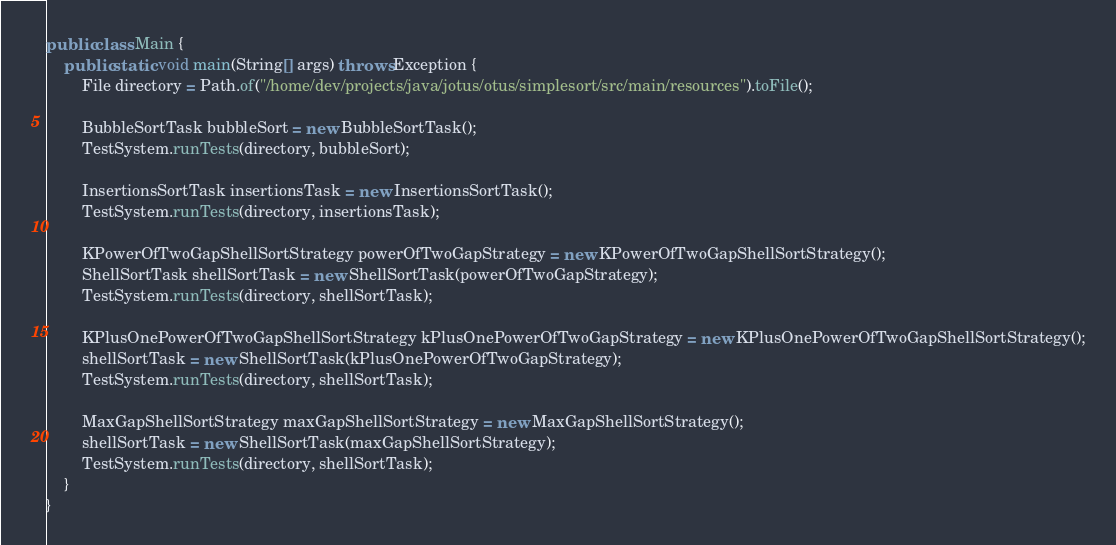<code> <loc_0><loc_0><loc_500><loc_500><_Java_>
public class Main {
    public static void main(String[] args) throws Exception {
        File directory = Path.of("/home/dev/projects/java/jotus/otus/simplesort/src/main/resources").toFile();

        BubbleSortTask bubbleSort = new BubbleSortTask();
        TestSystem.runTests(directory, bubbleSort);

        InsertionsSortTask insertionsTask = new InsertionsSortTask();
        TestSystem.runTests(directory, insertionsTask);

        KPowerOfTwoGapShellSortStrategy powerOfTwoGapStrategy = new KPowerOfTwoGapShellSortStrategy();
        ShellSortTask shellSortTask = new ShellSortTask(powerOfTwoGapStrategy);
        TestSystem.runTests(directory, shellSortTask);

        KPlusOnePowerOfTwoGapShellSortStrategy kPlusOnePowerOfTwoGapStrategy = new KPlusOnePowerOfTwoGapShellSortStrategy();
        shellSortTask = new ShellSortTask(kPlusOnePowerOfTwoGapStrategy);
        TestSystem.runTests(directory, shellSortTask);

        MaxGapShellSortStrategy maxGapShellSortStrategy = new MaxGapShellSortStrategy();
        shellSortTask = new ShellSortTask(maxGapShellSortStrategy);
        TestSystem.runTests(directory, shellSortTask);
    }
}
</code> 